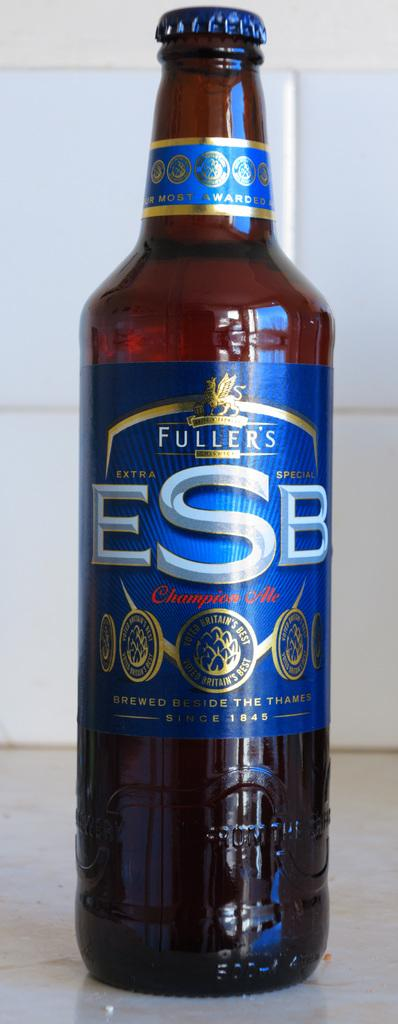What type of container is visible in the image? There is a brown glass bottle in the image. What is written on the label of the bottle? The label on the bottle has "Fuller's ESB" written on it. What type of comb is used to pickle the cherries in the image? There are no combs, pickles, or cherries present in the image. 